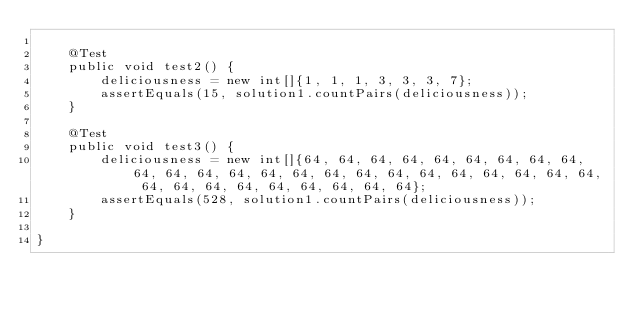Convert code to text. <code><loc_0><loc_0><loc_500><loc_500><_Java_>
    @Test
    public void test2() {
        deliciousness = new int[]{1, 1, 1, 3, 3, 3, 7};
        assertEquals(15, solution1.countPairs(deliciousness));
    }

    @Test
    public void test3() {
        deliciousness = new int[]{64, 64, 64, 64, 64, 64, 64, 64, 64, 64, 64, 64, 64, 64, 64, 64, 64, 64, 64, 64, 64, 64, 64, 64, 64, 64, 64, 64, 64, 64, 64, 64, 64};
        assertEquals(528, solution1.countPairs(deliciousness));
    }

}</code> 